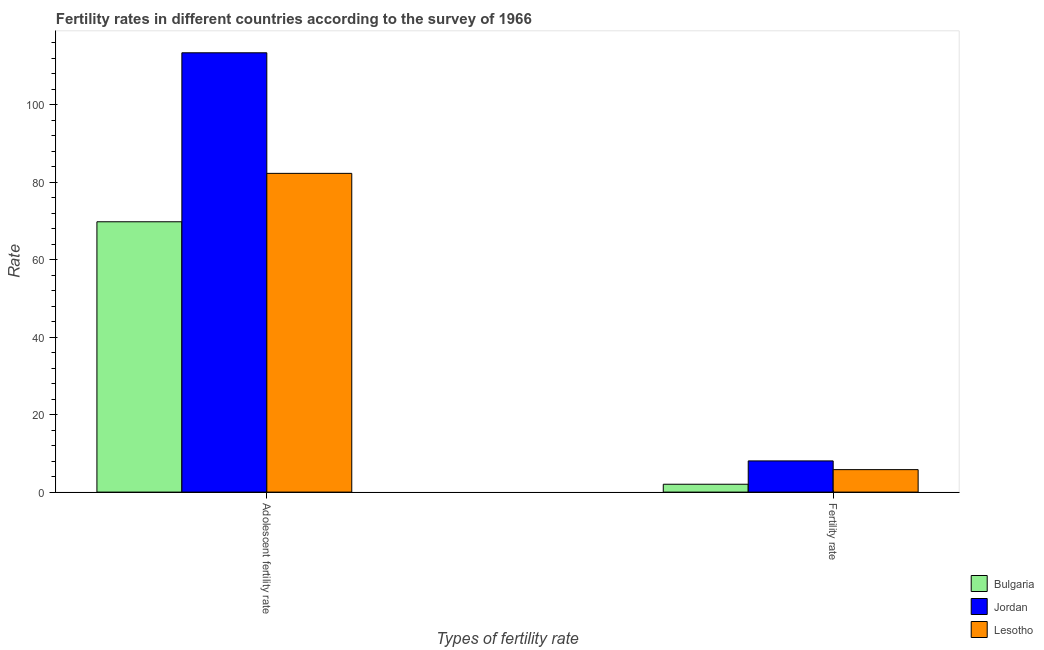Are the number of bars per tick equal to the number of legend labels?
Offer a very short reply. Yes. Are the number of bars on each tick of the X-axis equal?
Your answer should be very brief. Yes. How many bars are there on the 2nd tick from the left?
Provide a succinct answer. 3. What is the label of the 2nd group of bars from the left?
Provide a short and direct response. Fertility rate. What is the adolescent fertility rate in Jordan?
Ensure brevity in your answer.  113.4. Across all countries, what is the maximum adolescent fertility rate?
Make the answer very short. 113.4. Across all countries, what is the minimum adolescent fertility rate?
Offer a very short reply. 69.78. In which country was the fertility rate maximum?
Offer a very short reply. Jordan. In which country was the fertility rate minimum?
Keep it short and to the point. Bulgaria. What is the total fertility rate in the graph?
Provide a short and direct response. 15.88. What is the difference between the adolescent fertility rate in Bulgaria and that in Jordan?
Your response must be concise. -43.62. What is the difference between the fertility rate in Jordan and the adolescent fertility rate in Lesotho?
Offer a terse response. -74.22. What is the average fertility rate per country?
Ensure brevity in your answer.  5.29. What is the difference between the fertility rate and adolescent fertility rate in Jordan?
Offer a very short reply. -105.35. In how many countries, is the adolescent fertility rate greater than 100 ?
Make the answer very short. 1. What is the ratio of the adolescent fertility rate in Bulgaria to that in Jordan?
Offer a very short reply. 0.62. What does the 3rd bar from the left in Fertility rate represents?
Provide a succinct answer. Lesotho. What does the 1st bar from the right in Adolescent fertility rate represents?
Make the answer very short. Lesotho. How many bars are there?
Your response must be concise. 6. Are all the bars in the graph horizontal?
Provide a short and direct response. No. How many countries are there in the graph?
Provide a succinct answer. 3. Are the values on the major ticks of Y-axis written in scientific E-notation?
Offer a terse response. No. Does the graph contain any zero values?
Make the answer very short. No. What is the title of the graph?
Your answer should be compact. Fertility rates in different countries according to the survey of 1966. What is the label or title of the X-axis?
Ensure brevity in your answer.  Types of fertility rate. What is the label or title of the Y-axis?
Keep it short and to the point. Rate. What is the Rate of Bulgaria in Adolescent fertility rate?
Your answer should be compact. 69.78. What is the Rate of Jordan in Adolescent fertility rate?
Your answer should be compact. 113.4. What is the Rate of Lesotho in Adolescent fertility rate?
Make the answer very short. 82.28. What is the Rate of Bulgaria in Fertility rate?
Your response must be concise. 2.03. What is the Rate of Jordan in Fertility rate?
Offer a terse response. 8.05. What is the Rate of Lesotho in Fertility rate?
Make the answer very short. 5.8. Across all Types of fertility rate, what is the maximum Rate of Bulgaria?
Give a very brief answer. 69.78. Across all Types of fertility rate, what is the maximum Rate in Jordan?
Your response must be concise. 113.4. Across all Types of fertility rate, what is the maximum Rate in Lesotho?
Your response must be concise. 82.28. Across all Types of fertility rate, what is the minimum Rate of Bulgaria?
Give a very brief answer. 2.03. Across all Types of fertility rate, what is the minimum Rate in Jordan?
Give a very brief answer. 8.05. Across all Types of fertility rate, what is the minimum Rate in Lesotho?
Offer a very short reply. 5.8. What is the total Rate in Bulgaria in the graph?
Keep it short and to the point. 71.81. What is the total Rate of Jordan in the graph?
Keep it short and to the point. 121.45. What is the total Rate in Lesotho in the graph?
Provide a short and direct response. 88.08. What is the difference between the Rate of Bulgaria in Adolescent fertility rate and that in Fertility rate?
Make the answer very short. 67.75. What is the difference between the Rate of Jordan in Adolescent fertility rate and that in Fertility rate?
Offer a terse response. 105.35. What is the difference between the Rate in Lesotho in Adolescent fertility rate and that in Fertility rate?
Your response must be concise. 76.47. What is the difference between the Rate of Bulgaria in Adolescent fertility rate and the Rate of Jordan in Fertility rate?
Give a very brief answer. 61.73. What is the difference between the Rate of Bulgaria in Adolescent fertility rate and the Rate of Lesotho in Fertility rate?
Offer a terse response. 63.98. What is the difference between the Rate in Jordan in Adolescent fertility rate and the Rate in Lesotho in Fertility rate?
Make the answer very short. 107.6. What is the average Rate of Bulgaria per Types of fertility rate?
Your answer should be very brief. 35.9. What is the average Rate of Jordan per Types of fertility rate?
Your answer should be very brief. 60.73. What is the average Rate of Lesotho per Types of fertility rate?
Make the answer very short. 44.04. What is the difference between the Rate in Bulgaria and Rate in Jordan in Adolescent fertility rate?
Your response must be concise. -43.62. What is the difference between the Rate of Bulgaria and Rate of Lesotho in Adolescent fertility rate?
Provide a succinct answer. -12.5. What is the difference between the Rate of Jordan and Rate of Lesotho in Adolescent fertility rate?
Your answer should be very brief. 31.13. What is the difference between the Rate of Bulgaria and Rate of Jordan in Fertility rate?
Your answer should be very brief. -6.02. What is the difference between the Rate of Bulgaria and Rate of Lesotho in Fertility rate?
Keep it short and to the point. -3.77. What is the difference between the Rate in Jordan and Rate in Lesotho in Fertility rate?
Your answer should be compact. 2.25. What is the ratio of the Rate in Bulgaria in Adolescent fertility rate to that in Fertility rate?
Give a very brief answer. 34.37. What is the ratio of the Rate of Jordan in Adolescent fertility rate to that in Fertility rate?
Give a very brief answer. 14.08. What is the ratio of the Rate of Lesotho in Adolescent fertility rate to that in Fertility rate?
Your answer should be compact. 14.18. What is the difference between the highest and the second highest Rate of Bulgaria?
Ensure brevity in your answer.  67.75. What is the difference between the highest and the second highest Rate of Jordan?
Your response must be concise. 105.35. What is the difference between the highest and the second highest Rate of Lesotho?
Keep it short and to the point. 76.47. What is the difference between the highest and the lowest Rate of Bulgaria?
Your response must be concise. 67.75. What is the difference between the highest and the lowest Rate in Jordan?
Keep it short and to the point. 105.35. What is the difference between the highest and the lowest Rate in Lesotho?
Offer a terse response. 76.47. 